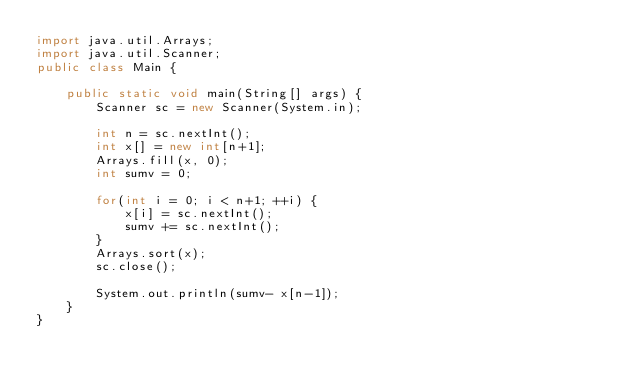Convert code to text. <code><loc_0><loc_0><loc_500><loc_500><_Java_>import java.util.Arrays;
import java.util.Scanner;
public class Main {

	public static void main(String[] args) {
		Scanner sc = new Scanner(System.in);

		int n = sc.nextInt();
		int x[] = new int[n+1];
		Arrays.fill(x, 0);
		int sumv = 0;
		
		for(int i = 0; i < n+1; ++i) {
			x[i] = sc.nextInt();
			sumv += sc.nextInt();
		}
		Arrays.sort(x);
		sc.close();
		
		System.out.println(sumv- x[n-1]);
	}
}</code> 